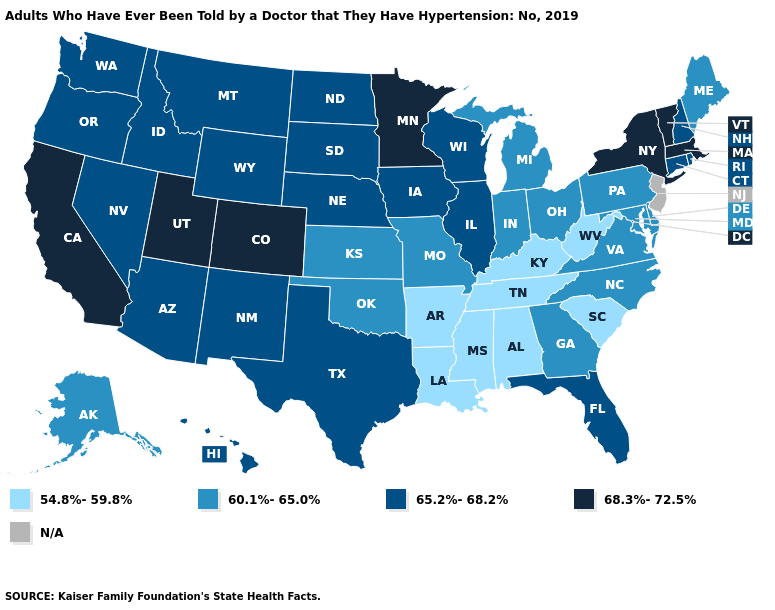Does the first symbol in the legend represent the smallest category?
Short answer required. Yes. Name the states that have a value in the range 54.8%-59.8%?
Quick response, please. Alabama, Arkansas, Kentucky, Louisiana, Mississippi, South Carolina, Tennessee, West Virginia. Is the legend a continuous bar?
Answer briefly. No. Name the states that have a value in the range 60.1%-65.0%?
Short answer required. Alaska, Delaware, Georgia, Indiana, Kansas, Maine, Maryland, Michigan, Missouri, North Carolina, Ohio, Oklahoma, Pennsylvania, Virginia. Name the states that have a value in the range N/A?
Answer briefly. New Jersey. Which states have the lowest value in the South?
Quick response, please. Alabama, Arkansas, Kentucky, Louisiana, Mississippi, South Carolina, Tennessee, West Virginia. Name the states that have a value in the range 68.3%-72.5%?
Quick response, please. California, Colorado, Massachusetts, Minnesota, New York, Utah, Vermont. Which states hav the highest value in the West?
Answer briefly. California, Colorado, Utah. What is the value of Massachusetts?
Short answer required. 68.3%-72.5%. What is the value of Massachusetts?
Write a very short answer. 68.3%-72.5%. How many symbols are there in the legend?
Answer briefly. 5. Name the states that have a value in the range 60.1%-65.0%?
Answer briefly. Alaska, Delaware, Georgia, Indiana, Kansas, Maine, Maryland, Michigan, Missouri, North Carolina, Ohio, Oklahoma, Pennsylvania, Virginia. 